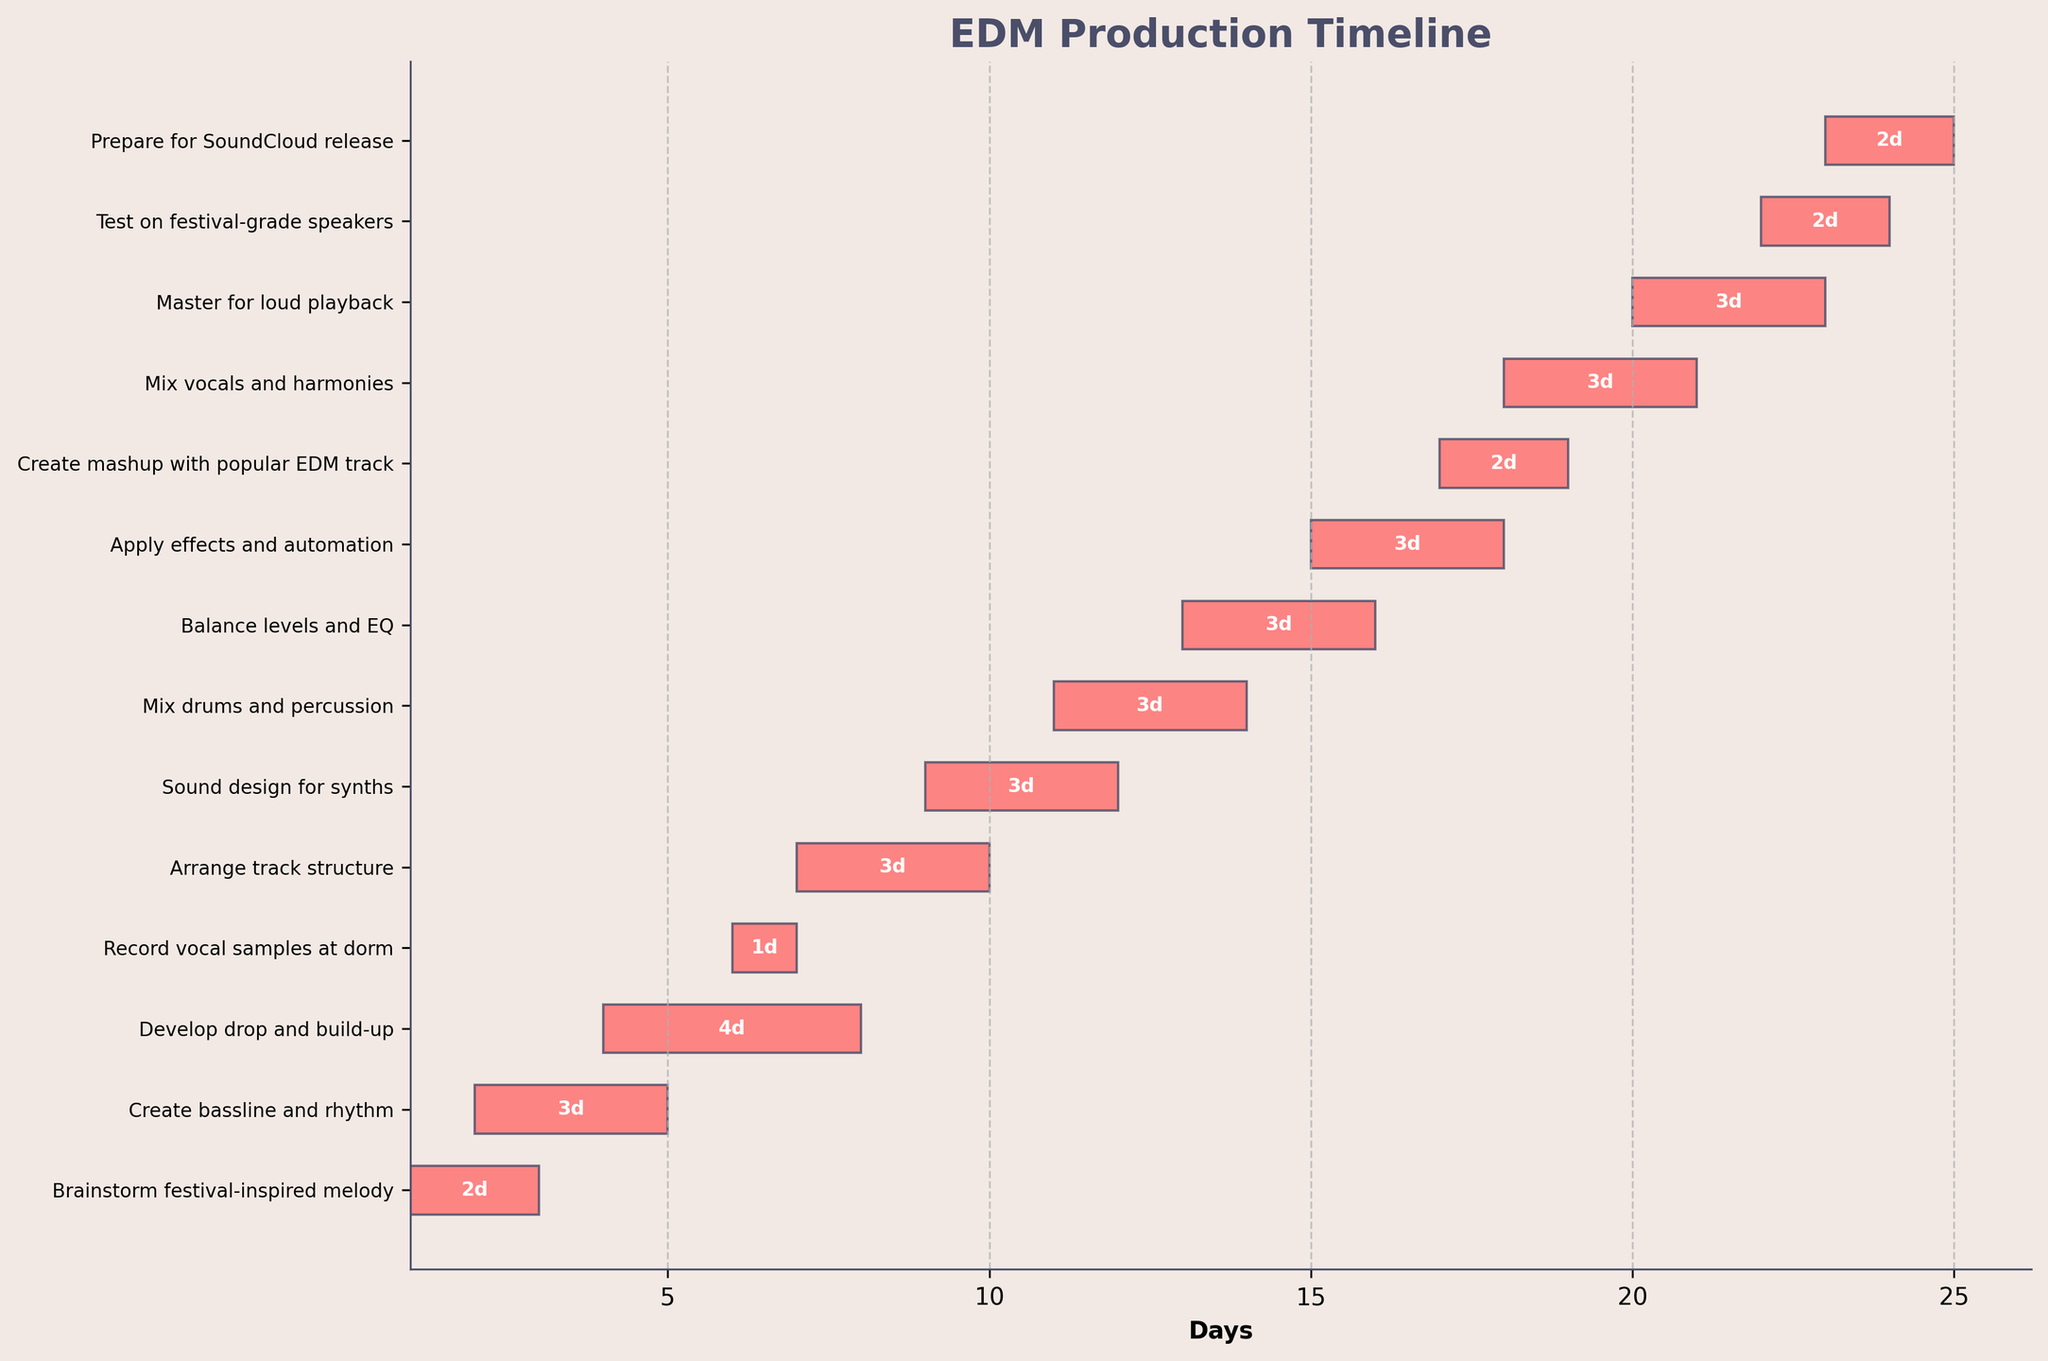What is the total duration of the "Master for loud playback" task? The "Master for loud playback" task starts on day 20 and ends on day 23. The total duration is 23 - 20 = 3 days
Answer: 3 days Which task overlaps with "Develop drop and build-up"? "Develop drop and build-up" runs from day 4 to day 8. The tasks "Create bassline and rhythm" (day 2 to day 5) and "Record vocal samples at dorm" (day 6 to day 7) overlap with it.
Answer: "Create bassline and rhythm" and "Record vocal samples at dorm" During which days is "Mix drums and percussion" active? The "Mix drums and percussion" task starts on day 11 and ends on day 14.
Answer: Days 11 to 14 How many days are spent on tasks before "Sound design for synths" starts? Tasks before "Sound design for synths" starts on day 9 are: "Brainstorm festival-inspired melody" (3 days), "Create bassline and rhythm" (4 days), "Develop drop and build-up" (4 days), and "Record vocal samples at dorm" (2 days). Summing these up: 3 + 4 + 4 + 2 = 13 days
Answer: 13 days What is the latest task to start? The latest task to start is "Prepare for SoundCloud release", which begins on day 23.
Answer: "Prepare for SoundCloud release" Which task has the shortest duration? By comparing the durations between tasks, "Record vocal samples at dorm" has the shortest duration of 1 day, from day 6 to day 7.
Answer: "Record vocal samples at dorm" How many tasks are carried out simultaneously during the day 18? On day 18, the tasks "Apply effects and automation," "Create mashup with popular EDM track," and "Mix vocals and harmonies" are all active.
Answer: 3 tasks What is the combined duration of "Mix vocals and harmonies" and "Balance levels and EQ"? "Mix vocals and harmonies" runs from day 18 to day 21 (4 days), and "Balance levels and EQ" runs from day 13 to day 16 (4 days). The combined duration is 4 + 4 = 8 days.
Answer: 8 days Is there any period in which no tasks overlap? From day 1 to day 2 and from day 24 to day 25, no tasks overlap.
Answer: Day 1-2 and Day 24-25 